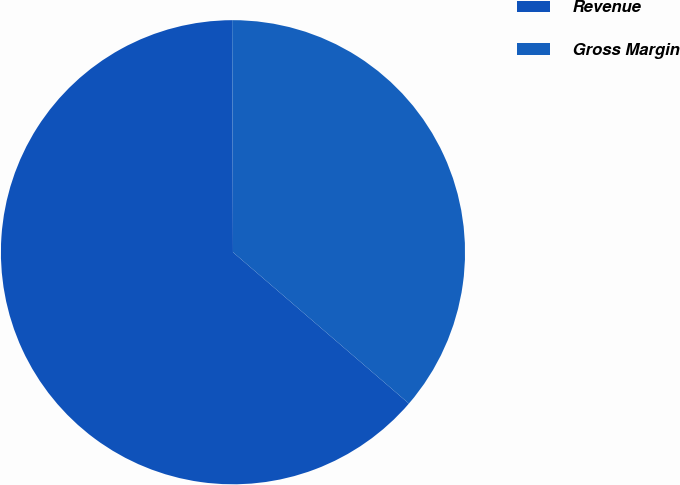Convert chart to OTSL. <chart><loc_0><loc_0><loc_500><loc_500><pie_chart><fcel>Revenue<fcel>Gross Margin<nl><fcel>63.64%<fcel>36.36%<nl></chart> 